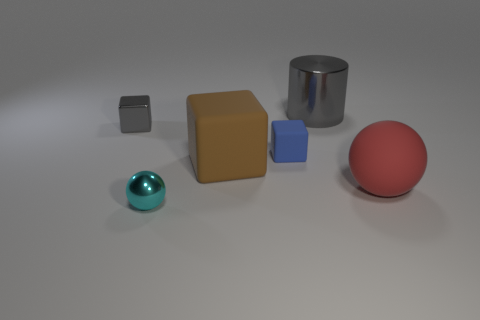Subtract all big brown blocks. How many blocks are left? 2 Add 2 tiny blocks. How many objects exist? 8 Subtract all cyan balls. How many balls are left? 1 Subtract 2 blocks. How many blocks are left? 1 Subtract all spheres. How many objects are left? 4 Add 3 small blue rubber blocks. How many small blue rubber blocks exist? 4 Subtract 0 red blocks. How many objects are left? 6 Subtract all red blocks. Subtract all red spheres. How many blocks are left? 3 Subtract all gray balls. How many blue cubes are left? 1 Subtract all tiny things. Subtract all big shiny things. How many objects are left? 2 